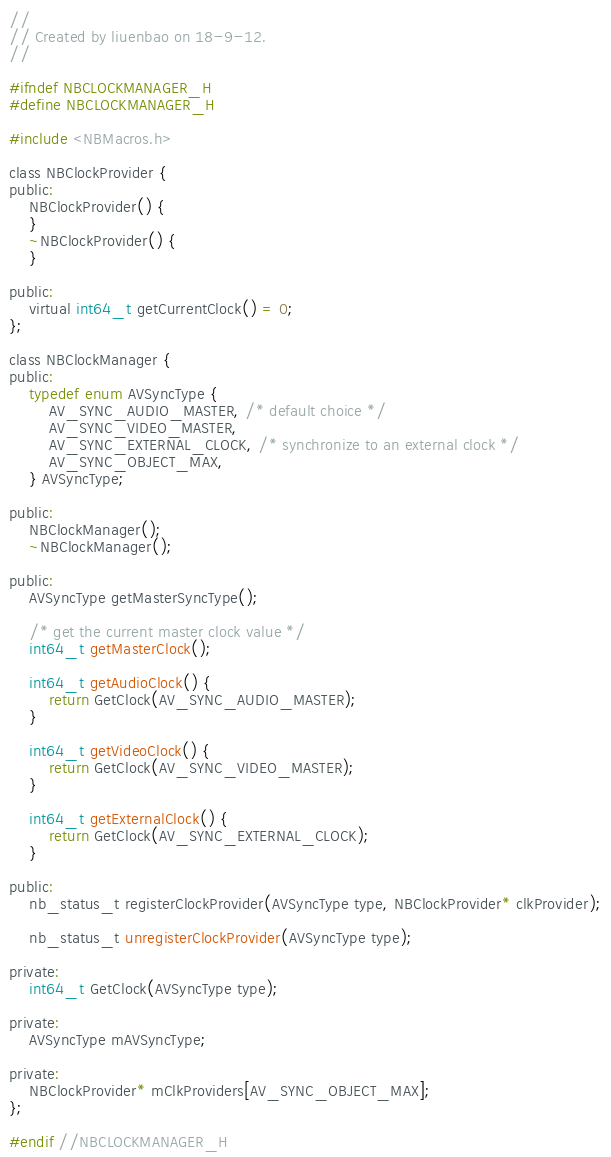Convert code to text. <code><loc_0><loc_0><loc_500><loc_500><_C_>//
// Created by liuenbao on 18-9-12.
//

#ifndef NBCLOCKMANAGER_H
#define NBCLOCKMANAGER_H

#include <NBMacros.h>

class NBClockProvider {
public:
    NBClockProvider() {
    }
    ~NBClockProvider() {
    }

public:
    virtual int64_t getCurrentClock() = 0;
};

class NBClockManager {
public:
    typedef enum AVSyncType {
        AV_SYNC_AUDIO_MASTER, /* default choice */
        AV_SYNC_VIDEO_MASTER,
        AV_SYNC_EXTERNAL_CLOCK, /* synchronize to an external clock */
        AV_SYNC_OBJECT_MAX,
    } AVSyncType;

public:
    NBClockManager();
    ~NBClockManager();

public:
    AVSyncType getMasterSyncType();

    /* get the current master clock value */
    int64_t getMasterClock();

    int64_t getAudioClock() {
        return GetClock(AV_SYNC_AUDIO_MASTER);
    }

    int64_t getVideoClock() {
        return GetClock(AV_SYNC_VIDEO_MASTER);
    }

    int64_t getExternalClock() {
        return GetClock(AV_SYNC_EXTERNAL_CLOCK);
    }

public:
    nb_status_t registerClockProvider(AVSyncType type, NBClockProvider* clkProvider);

    nb_status_t unregisterClockProvider(AVSyncType type);

private:
    int64_t GetClock(AVSyncType type);

private:
    AVSyncType mAVSyncType;

private:
    NBClockProvider* mClkProviders[AV_SYNC_OBJECT_MAX];
};

#endif //NBCLOCKMANAGER_H
</code> 